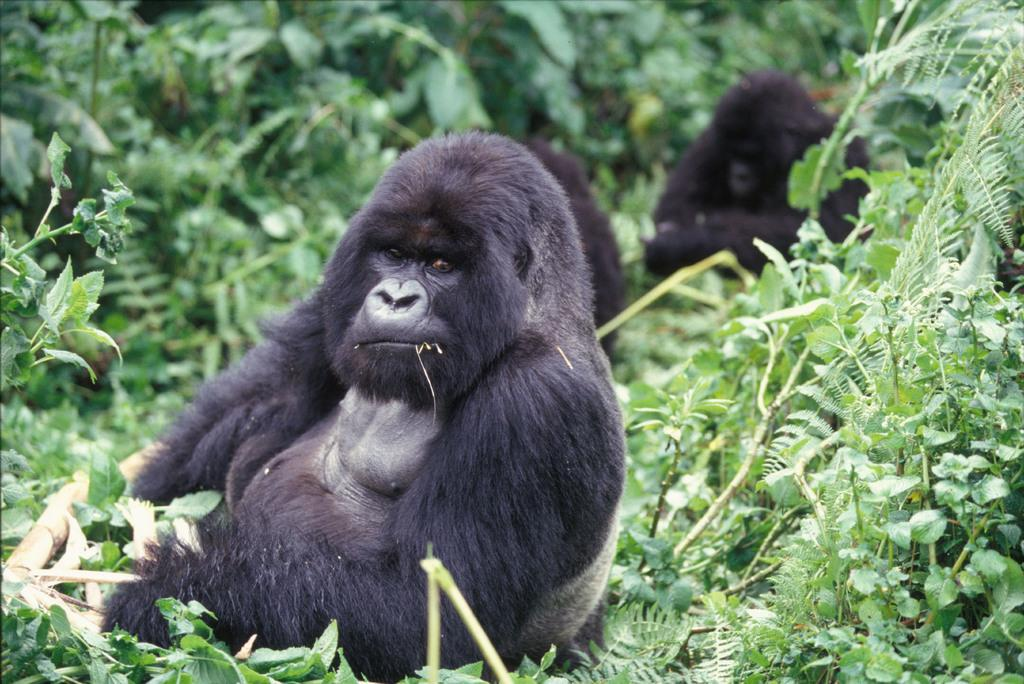How many gorillas are present in the image? There are three gorillas in the image. What is the environment like in the image? The gorillas are surrounded by trees in the image. What invention can be seen in the hands of the gorillas in the image? There are no inventions present in the image; the gorillas are not holding any objects. 